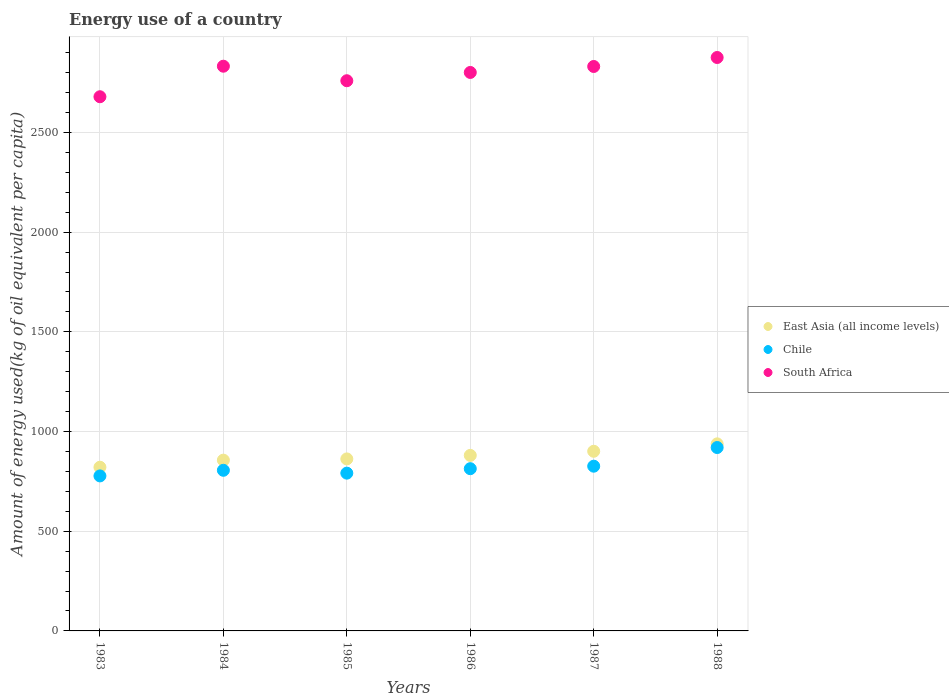What is the amount of energy used in in Chile in 1988?
Give a very brief answer. 919.89. Across all years, what is the maximum amount of energy used in in Chile?
Your answer should be compact. 919.89. Across all years, what is the minimum amount of energy used in in Chile?
Provide a succinct answer. 777.5. What is the total amount of energy used in in East Asia (all income levels) in the graph?
Make the answer very short. 5260.38. What is the difference between the amount of energy used in in South Africa in 1985 and that in 1986?
Ensure brevity in your answer.  -41.53. What is the difference between the amount of energy used in in East Asia (all income levels) in 1983 and the amount of energy used in in Chile in 1986?
Give a very brief answer. 7.35. What is the average amount of energy used in in East Asia (all income levels) per year?
Keep it short and to the point. 876.73. In the year 1984, what is the difference between the amount of energy used in in South Africa and amount of energy used in in Chile?
Your answer should be very brief. 2026.84. In how many years, is the amount of energy used in in South Africa greater than 200 kg?
Make the answer very short. 6. What is the ratio of the amount of energy used in in East Asia (all income levels) in 1985 to that in 1986?
Your response must be concise. 0.98. What is the difference between the highest and the second highest amount of energy used in in Chile?
Make the answer very short. 93.63. What is the difference between the highest and the lowest amount of energy used in in South Africa?
Your answer should be compact. 196.85. Is the amount of energy used in in Chile strictly greater than the amount of energy used in in East Asia (all income levels) over the years?
Your answer should be very brief. No. How many dotlines are there?
Offer a very short reply. 3. What is the difference between two consecutive major ticks on the Y-axis?
Keep it short and to the point. 500. Where does the legend appear in the graph?
Provide a succinct answer. Center right. How are the legend labels stacked?
Offer a terse response. Vertical. What is the title of the graph?
Provide a succinct answer. Energy use of a country. Does "New Zealand" appear as one of the legend labels in the graph?
Offer a very short reply. No. What is the label or title of the Y-axis?
Your answer should be compact. Amount of energy used(kg of oil equivalent per capita). What is the Amount of energy used(kg of oil equivalent per capita) in East Asia (all income levels) in 1983?
Provide a succinct answer. 821.1. What is the Amount of energy used(kg of oil equivalent per capita) in Chile in 1983?
Your answer should be compact. 777.5. What is the Amount of energy used(kg of oil equivalent per capita) in South Africa in 1983?
Make the answer very short. 2679.38. What is the Amount of energy used(kg of oil equivalent per capita) in East Asia (all income levels) in 1984?
Offer a terse response. 856.58. What is the Amount of energy used(kg of oil equivalent per capita) in Chile in 1984?
Provide a short and direct response. 805.69. What is the Amount of energy used(kg of oil equivalent per capita) of South Africa in 1984?
Your response must be concise. 2832.52. What is the Amount of energy used(kg of oil equivalent per capita) in East Asia (all income levels) in 1985?
Make the answer very short. 862.8. What is the Amount of energy used(kg of oil equivalent per capita) in Chile in 1985?
Offer a very short reply. 791.4. What is the Amount of energy used(kg of oil equivalent per capita) of South Africa in 1985?
Your answer should be compact. 2759.69. What is the Amount of energy used(kg of oil equivalent per capita) in East Asia (all income levels) in 1986?
Provide a short and direct response. 880.44. What is the Amount of energy used(kg of oil equivalent per capita) in Chile in 1986?
Your answer should be compact. 813.75. What is the Amount of energy used(kg of oil equivalent per capita) of South Africa in 1986?
Your answer should be compact. 2801.22. What is the Amount of energy used(kg of oil equivalent per capita) in East Asia (all income levels) in 1987?
Your response must be concise. 901.11. What is the Amount of energy used(kg of oil equivalent per capita) of Chile in 1987?
Provide a succinct answer. 826.26. What is the Amount of energy used(kg of oil equivalent per capita) of South Africa in 1987?
Your response must be concise. 2831.15. What is the Amount of energy used(kg of oil equivalent per capita) in East Asia (all income levels) in 1988?
Offer a very short reply. 938.34. What is the Amount of energy used(kg of oil equivalent per capita) of Chile in 1988?
Your answer should be compact. 919.89. What is the Amount of energy used(kg of oil equivalent per capita) in South Africa in 1988?
Provide a short and direct response. 2876.23. Across all years, what is the maximum Amount of energy used(kg of oil equivalent per capita) of East Asia (all income levels)?
Provide a succinct answer. 938.34. Across all years, what is the maximum Amount of energy used(kg of oil equivalent per capita) of Chile?
Your response must be concise. 919.89. Across all years, what is the maximum Amount of energy used(kg of oil equivalent per capita) of South Africa?
Provide a short and direct response. 2876.23. Across all years, what is the minimum Amount of energy used(kg of oil equivalent per capita) of East Asia (all income levels)?
Ensure brevity in your answer.  821.1. Across all years, what is the minimum Amount of energy used(kg of oil equivalent per capita) in Chile?
Give a very brief answer. 777.5. Across all years, what is the minimum Amount of energy used(kg of oil equivalent per capita) in South Africa?
Your response must be concise. 2679.38. What is the total Amount of energy used(kg of oil equivalent per capita) in East Asia (all income levels) in the graph?
Provide a succinct answer. 5260.38. What is the total Amount of energy used(kg of oil equivalent per capita) in Chile in the graph?
Ensure brevity in your answer.  4934.48. What is the total Amount of energy used(kg of oil equivalent per capita) in South Africa in the graph?
Your response must be concise. 1.68e+04. What is the difference between the Amount of energy used(kg of oil equivalent per capita) of East Asia (all income levels) in 1983 and that in 1984?
Offer a very short reply. -35.48. What is the difference between the Amount of energy used(kg of oil equivalent per capita) in Chile in 1983 and that in 1984?
Provide a short and direct response. -28.19. What is the difference between the Amount of energy used(kg of oil equivalent per capita) in South Africa in 1983 and that in 1984?
Provide a short and direct response. -153.14. What is the difference between the Amount of energy used(kg of oil equivalent per capita) of East Asia (all income levels) in 1983 and that in 1985?
Ensure brevity in your answer.  -41.69. What is the difference between the Amount of energy used(kg of oil equivalent per capita) of Chile in 1983 and that in 1985?
Ensure brevity in your answer.  -13.9. What is the difference between the Amount of energy used(kg of oil equivalent per capita) in South Africa in 1983 and that in 1985?
Offer a terse response. -80.31. What is the difference between the Amount of energy used(kg of oil equivalent per capita) in East Asia (all income levels) in 1983 and that in 1986?
Provide a short and direct response. -59.34. What is the difference between the Amount of energy used(kg of oil equivalent per capita) of Chile in 1983 and that in 1986?
Make the answer very short. -36.26. What is the difference between the Amount of energy used(kg of oil equivalent per capita) of South Africa in 1983 and that in 1986?
Provide a short and direct response. -121.84. What is the difference between the Amount of energy used(kg of oil equivalent per capita) of East Asia (all income levels) in 1983 and that in 1987?
Provide a short and direct response. -80. What is the difference between the Amount of energy used(kg of oil equivalent per capita) of Chile in 1983 and that in 1987?
Ensure brevity in your answer.  -48.77. What is the difference between the Amount of energy used(kg of oil equivalent per capita) in South Africa in 1983 and that in 1987?
Offer a very short reply. -151.77. What is the difference between the Amount of energy used(kg of oil equivalent per capita) in East Asia (all income levels) in 1983 and that in 1988?
Provide a succinct answer. -117.24. What is the difference between the Amount of energy used(kg of oil equivalent per capita) of Chile in 1983 and that in 1988?
Make the answer very short. -142.4. What is the difference between the Amount of energy used(kg of oil equivalent per capita) in South Africa in 1983 and that in 1988?
Your answer should be very brief. -196.85. What is the difference between the Amount of energy used(kg of oil equivalent per capita) of East Asia (all income levels) in 1984 and that in 1985?
Your answer should be very brief. -6.21. What is the difference between the Amount of energy used(kg of oil equivalent per capita) in Chile in 1984 and that in 1985?
Ensure brevity in your answer.  14.29. What is the difference between the Amount of energy used(kg of oil equivalent per capita) in South Africa in 1984 and that in 1985?
Your answer should be compact. 72.83. What is the difference between the Amount of energy used(kg of oil equivalent per capita) of East Asia (all income levels) in 1984 and that in 1986?
Your answer should be compact. -23.86. What is the difference between the Amount of energy used(kg of oil equivalent per capita) of Chile in 1984 and that in 1986?
Your answer should be compact. -8.07. What is the difference between the Amount of energy used(kg of oil equivalent per capita) of South Africa in 1984 and that in 1986?
Keep it short and to the point. 31.3. What is the difference between the Amount of energy used(kg of oil equivalent per capita) of East Asia (all income levels) in 1984 and that in 1987?
Make the answer very short. -44.53. What is the difference between the Amount of energy used(kg of oil equivalent per capita) in Chile in 1984 and that in 1987?
Offer a terse response. -20.57. What is the difference between the Amount of energy used(kg of oil equivalent per capita) of South Africa in 1984 and that in 1987?
Offer a terse response. 1.38. What is the difference between the Amount of energy used(kg of oil equivalent per capita) of East Asia (all income levels) in 1984 and that in 1988?
Offer a very short reply. -81.76. What is the difference between the Amount of energy used(kg of oil equivalent per capita) of Chile in 1984 and that in 1988?
Your answer should be very brief. -114.2. What is the difference between the Amount of energy used(kg of oil equivalent per capita) of South Africa in 1984 and that in 1988?
Offer a very short reply. -43.71. What is the difference between the Amount of energy used(kg of oil equivalent per capita) of East Asia (all income levels) in 1985 and that in 1986?
Provide a short and direct response. -17.65. What is the difference between the Amount of energy used(kg of oil equivalent per capita) of Chile in 1985 and that in 1986?
Your response must be concise. -22.36. What is the difference between the Amount of energy used(kg of oil equivalent per capita) in South Africa in 1985 and that in 1986?
Give a very brief answer. -41.53. What is the difference between the Amount of energy used(kg of oil equivalent per capita) of East Asia (all income levels) in 1985 and that in 1987?
Offer a terse response. -38.31. What is the difference between the Amount of energy used(kg of oil equivalent per capita) in Chile in 1985 and that in 1987?
Offer a very short reply. -34.87. What is the difference between the Amount of energy used(kg of oil equivalent per capita) of South Africa in 1985 and that in 1987?
Your response must be concise. -71.46. What is the difference between the Amount of energy used(kg of oil equivalent per capita) of East Asia (all income levels) in 1985 and that in 1988?
Provide a short and direct response. -75.55. What is the difference between the Amount of energy used(kg of oil equivalent per capita) in Chile in 1985 and that in 1988?
Give a very brief answer. -128.49. What is the difference between the Amount of energy used(kg of oil equivalent per capita) of South Africa in 1985 and that in 1988?
Your answer should be compact. -116.54. What is the difference between the Amount of energy used(kg of oil equivalent per capita) in East Asia (all income levels) in 1986 and that in 1987?
Offer a very short reply. -20.67. What is the difference between the Amount of energy used(kg of oil equivalent per capita) of Chile in 1986 and that in 1987?
Give a very brief answer. -12.51. What is the difference between the Amount of energy used(kg of oil equivalent per capita) in South Africa in 1986 and that in 1987?
Keep it short and to the point. -29.93. What is the difference between the Amount of energy used(kg of oil equivalent per capita) in East Asia (all income levels) in 1986 and that in 1988?
Your answer should be very brief. -57.9. What is the difference between the Amount of energy used(kg of oil equivalent per capita) of Chile in 1986 and that in 1988?
Your response must be concise. -106.14. What is the difference between the Amount of energy used(kg of oil equivalent per capita) in South Africa in 1986 and that in 1988?
Keep it short and to the point. -75.01. What is the difference between the Amount of energy used(kg of oil equivalent per capita) in East Asia (all income levels) in 1987 and that in 1988?
Your answer should be very brief. -37.23. What is the difference between the Amount of energy used(kg of oil equivalent per capita) of Chile in 1987 and that in 1988?
Offer a terse response. -93.63. What is the difference between the Amount of energy used(kg of oil equivalent per capita) in South Africa in 1987 and that in 1988?
Offer a very short reply. -45.08. What is the difference between the Amount of energy used(kg of oil equivalent per capita) in East Asia (all income levels) in 1983 and the Amount of energy used(kg of oil equivalent per capita) in Chile in 1984?
Offer a very short reply. 15.42. What is the difference between the Amount of energy used(kg of oil equivalent per capita) in East Asia (all income levels) in 1983 and the Amount of energy used(kg of oil equivalent per capita) in South Africa in 1984?
Give a very brief answer. -2011.42. What is the difference between the Amount of energy used(kg of oil equivalent per capita) of Chile in 1983 and the Amount of energy used(kg of oil equivalent per capita) of South Africa in 1984?
Make the answer very short. -2055.03. What is the difference between the Amount of energy used(kg of oil equivalent per capita) of East Asia (all income levels) in 1983 and the Amount of energy used(kg of oil equivalent per capita) of Chile in 1985?
Provide a succinct answer. 29.71. What is the difference between the Amount of energy used(kg of oil equivalent per capita) in East Asia (all income levels) in 1983 and the Amount of energy used(kg of oil equivalent per capita) in South Africa in 1985?
Ensure brevity in your answer.  -1938.59. What is the difference between the Amount of energy used(kg of oil equivalent per capita) in Chile in 1983 and the Amount of energy used(kg of oil equivalent per capita) in South Africa in 1985?
Your answer should be very brief. -1982.2. What is the difference between the Amount of energy used(kg of oil equivalent per capita) of East Asia (all income levels) in 1983 and the Amount of energy used(kg of oil equivalent per capita) of Chile in 1986?
Your answer should be compact. 7.35. What is the difference between the Amount of energy used(kg of oil equivalent per capita) in East Asia (all income levels) in 1983 and the Amount of energy used(kg of oil equivalent per capita) in South Africa in 1986?
Give a very brief answer. -1980.12. What is the difference between the Amount of energy used(kg of oil equivalent per capita) in Chile in 1983 and the Amount of energy used(kg of oil equivalent per capita) in South Africa in 1986?
Your answer should be very brief. -2023.72. What is the difference between the Amount of energy used(kg of oil equivalent per capita) of East Asia (all income levels) in 1983 and the Amount of energy used(kg of oil equivalent per capita) of Chile in 1987?
Provide a short and direct response. -5.16. What is the difference between the Amount of energy used(kg of oil equivalent per capita) of East Asia (all income levels) in 1983 and the Amount of energy used(kg of oil equivalent per capita) of South Africa in 1987?
Provide a short and direct response. -2010.04. What is the difference between the Amount of energy used(kg of oil equivalent per capita) in Chile in 1983 and the Amount of energy used(kg of oil equivalent per capita) in South Africa in 1987?
Offer a terse response. -2053.65. What is the difference between the Amount of energy used(kg of oil equivalent per capita) in East Asia (all income levels) in 1983 and the Amount of energy used(kg of oil equivalent per capita) in Chile in 1988?
Provide a succinct answer. -98.79. What is the difference between the Amount of energy used(kg of oil equivalent per capita) in East Asia (all income levels) in 1983 and the Amount of energy used(kg of oil equivalent per capita) in South Africa in 1988?
Your response must be concise. -2055.13. What is the difference between the Amount of energy used(kg of oil equivalent per capita) in Chile in 1983 and the Amount of energy used(kg of oil equivalent per capita) in South Africa in 1988?
Ensure brevity in your answer.  -2098.74. What is the difference between the Amount of energy used(kg of oil equivalent per capita) of East Asia (all income levels) in 1984 and the Amount of energy used(kg of oil equivalent per capita) of Chile in 1985?
Give a very brief answer. 65.19. What is the difference between the Amount of energy used(kg of oil equivalent per capita) of East Asia (all income levels) in 1984 and the Amount of energy used(kg of oil equivalent per capita) of South Africa in 1985?
Give a very brief answer. -1903.11. What is the difference between the Amount of energy used(kg of oil equivalent per capita) of Chile in 1984 and the Amount of energy used(kg of oil equivalent per capita) of South Africa in 1985?
Ensure brevity in your answer.  -1954. What is the difference between the Amount of energy used(kg of oil equivalent per capita) in East Asia (all income levels) in 1984 and the Amount of energy used(kg of oil equivalent per capita) in Chile in 1986?
Your answer should be compact. 42.83. What is the difference between the Amount of energy used(kg of oil equivalent per capita) in East Asia (all income levels) in 1984 and the Amount of energy used(kg of oil equivalent per capita) in South Africa in 1986?
Make the answer very short. -1944.64. What is the difference between the Amount of energy used(kg of oil equivalent per capita) in Chile in 1984 and the Amount of energy used(kg of oil equivalent per capita) in South Africa in 1986?
Give a very brief answer. -1995.53. What is the difference between the Amount of energy used(kg of oil equivalent per capita) of East Asia (all income levels) in 1984 and the Amount of energy used(kg of oil equivalent per capita) of Chile in 1987?
Offer a terse response. 30.32. What is the difference between the Amount of energy used(kg of oil equivalent per capita) in East Asia (all income levels) in 1984 and the Amount of energy used(kg of oil equivalent per capita) in South Africa in 1987?
Provide a short and direct response. -1974.57. What is the difference between the Amount of energy used(kg of oil equivalent per capita) in Chile in 1984 and the Amount of energy used(kg of oil equivalent per capita) in South Africa in 1987?
Keep it short and to the point. -2025.46. What is the difference between the Amount of energy used(kg of oil equivalent per capita) in East Asia (all income levels) in 1984 and the Amount of energy used(kg of oil equivalent per capita) in Chile in 1988?
Offer a very short reply. -63.31. What is the difference between the Amount of energy used(kg of oil equivalent per capita) in East Asia (all income levels) in 1984 and the Amount of energy used(kg of oil equivalent per capita) in South Africa in 1988?
Give a very brief answer. -2019.65. What is the difference between the Amount of energy used(kg of oil equivalent per capita) of Chile in 1984 and the Amount of energy used(kg of oil equivalent per capita) of South Africa in 1988?
Your answer should be compact. -2070.54. What is the difference between the Amount of energy used(kg of oil equivalent per capita) in East Asia (all income levels) in 1985 and the Amount of energy used(kg of oil equivalent per capita) in Chile in 1986?
Provide a short and direct response. 49.04. What is the difference between the Amount of energy used(kg of oil equivalent per capita) of East Asia (all income levels) in 1985 and the Amount of energy used(kg of oil equivalent per capita) of South Africa in 1986?
Ensure brevity in your answer.  -1938.42. What is the difference between the Amount of energy used(kg of oil equivalent per capita) of Chile in 1985 and the Amount of energy used(kg of oil equivalent per capita) of South Africa in 1986?
Your answer should be very brief. -2009.82. What is the difference between the Amount of energy used(kg of oil equivalent per capita) in East Asia (all income levels) in 1985 and the Amount of energy used(kg of oil equivalent per capita) in Chile in 1987?
Make the answer very short. 36.53. What is the difference between the Amount of energy used(kg of oil equivalent per capita) of East Asia (all income levels) in 1985 and the Amount of energy used(kg of oil equivalent per capita) of South Africa in 1987?
Ensure brevity in your answer.  -1968.35. What is the difference between the Amount of energy used(kg of oil equivalent per capita) of Chile in 1985 and the Amount of energy used(kg of oil equivalent per capita) of South Africa in 1987?
Offer a terse response. -2039.75. What is the difference between the Amount of energy used(kg of oil equivalent per capita) of East Asia (all income levels) in 1985 and the Amount of energy used(kg of oil equivalent per capita) of Chile in 1988?
Your response must be concise. -57.09. What is the difference between the Amount of energy used(kg of oil equivalent per capita) of East Asia (all income levels) in 1985 and the Amount of energy used(kg of oil equivalent per capita) of South Africa in 1988?
Keep it short and to the point. -2013.44. What is the difference between the Amount of energy used(kg of oil equivalent per capita) of Chile in 1985 and the Amount of energy used(kg of oil equivalent per capita) of South Africa in 1988?
Keep it short and to the point. -2084.84. What is the difference between the Amount of energy used(kg of oil equivalent per capita) in East Asia (all income levels) in 1986 and the Amount of energy used(kg of oil equivalent per capita) in Chile in 1987?
Offer a very short reply. 54.18. What is the difference between the Amount of energy used(kg of oil equivalent per capita) in East Asia (all income levels) in 1986 and the Amount of energy used(kg of oil equivalent per capita) in South Africa in 1987?
Ensure brevity in your answer.  -1950.7. What is the difference between the Amount of energy used(kg of oil equivalent per capita) in Chile in 1986 and the Amount of energy used(kg of oil equivalent per capita) in South Africa in 1987?
Your answer should be compact. -2017.4. What is the difference between the Amount of energy used(kg of oil equivalent per capita) in East Asia (all income levels) in 1986 and the Amount of energy used(kg of oil equivalent per capita) in Chile in 1988?
Offer a very short reply. -39.45. What is the difference between the Amount of energy used(kg of oil equivalent per capita) in East Asia (all income levels) in 1986 and the Amount of energy used(kg of oil equivalent per capita) in South Africa in 1988?
Your answer should be very brief. -1995.79. What is the difference between the Amount of energy used(kg of oil equivalent per capita) of Chile in 1986 and the Amount of energy used(kg of oil equivalent per capita) of South Africa in 1988?
Provide a succinct answer. -2062.48. What is the difference between the Amount of energy used(kg of oil equivalent per capita) of East Asia (all income levels) in 1987 and the Amount of energy used(kg of oil equivalent per capita) of Chile in 1988?
Ensure brevity in your answer.  -18.78. What is the difference between the Amount of energy used(kg of oil equivalent per capita) in East Asia (all income levels) in 1987 and the Amount of energy used(kg of oil equivalent per capita) in South Africa in 1988?
Offer a terse response. -1975.12. What is the difference between the Amount of energy used(kg of oil equivalent per capita) of Chile in 1987 and the Amount of energy used(kg of oil equivalent per capita) of South Africa in 1988?
Keep it short and to the point. -2049.97. What is the average Amount of energy used(kg of oil equivalent per capita) in East Asia (all income levels) per year?
Make the answer very short. 876.73. What is the average Amount of energy used(kg of oil equivalent per capita) of Chile per year?
Your answer should be very brief. 822.41. What is the average Amount of energy used(kg of oil equivalent per capita) of South Africa per year?
Provide a succinct answer. 2796.7. In the year 1983, what is the difference between the Amount of energy used(kg of oil equivalent per capita) in East Asia (all income levels) and Amount of energy used(kg of oil equivalent per capita) in Chile?
Provide a succinct answer. 43.61. In the year 1983, what is the difference between the Amount of energy used(kg of oil equivalent per capita) of East Asia (all income levels) and Amount of energy used(kg of oil equivalent per capita) of South Africa?
Make the answer very short. -1858.27. In the year 1983, what is the difference between the Amount of energy used(kg of oil equivalent per capita) of Chile and Amount of energy used(kg of oil equivalent per capita) of South Africa?
Your answer should be very brief. -1901.88. In the year 1984, what is the difference between the Amount of energy used(kg of oil equivalent per capita) in East Asia (all income levels) and Amount of energy used(kg of oil equivalent per capita) in Chile?
Keep it short and to the point. 50.9. In the year 1984, what is the difference between the Amount of energy used(kg of oil equivalent per capita) of East Asia (all income levels) and Amount of energy used(kg of oil equivalent per capita) of South Africa?
Your answer should be very brief. -1975.94. In the year 1984, what is the difference between the Amount of energy used(kg of oil equivalent per capita) of Chile and Amount of energy used(kg of oil equivalent per capita) of South Africa?
Give a very brief answer. -2026.84. In the year 1985, what is the difference between the Amount of energy used(kg of oil equivalent per capita) of East Asia (all income levels) and Amount of energy used(kg of oil equivalent per capita) of Chile?
Provide a short and direct response. 71.4. In the year 1985, what is the difference between the Amount of energy used(kg of oil equivalent per capita) in East Asia (all income levels) and Amount of energy used(kg of oil equivalent per capita) in South Africa?
Offer a terse response. -1896.9. In the year 1985, what is the difference between the Amount of energy used(kg of oil equivalent per capita) of Chile and Amount of energy used(kg of oil equivalent per capita) of South Africa?
Give a very brief answer. -1968.3. In the year 1986, what is the difference between the Amount of energy used(kg of oil equivalent per capita) in East Asia (all income levels) and Amount of energy used(kg of oil equivalent per capita) in Chile?
Make the answer very short. 66.69. In the year 1986, what is the difference between the Amount of energy used(kg of oil equivalent per capita) of East Asia (all income levels) and Amount of energy used(kg of oil equivalent per capita) of South Africa?
Provide a short and direct response. -1920.78. In the year 1986, what is the difference between the Amount of energy used(kg of oil equivalent per capita) in Chile and Amount of energy used(kg of oil equivalent per capita) in South Africa?
Offer a terse response. -1987.47. In the year 1987, what is the difference between the Amount of energy used(kg of oil equivalent per capita) in East Asia (all income levels) and Amount of energy used(kg of oil equivalent per capita) in Chile?
Offer a terse response. 74.85. In the year 1987, what is the difference between the Amount of energy used(kg of oil equivalent per capita) of East Asia (all income levels) and Amount of energy used(kg of oil equivalent per capita) of South Africa?
Your answer should be compact. -1930.04. In the year 1987, what is the difference between the Amount of energy used(kg of oil equivalent per capita) of Chile and Amount of energy used(kg of oil equivalent per capita) of South Africa?
Offer a very short reply. -2004.89. In the year 1988, what is the difference between the Amount of energy used(kg of oil equivalent per capita) of East Asia (all income levels) and Amount of energy used(kg of oil equivalent per capita) of Chile?
Ensure brevity in your answer.  18.45. In the year 1988, what is the difference between the Amount of energy used(kg of oil equivalent per capita) in East Asia (all income levels) and Amount of energy used(kg of oil equivalent per capita) in South Africa?
Provide a short and direct response. -1937.89. In the year 1988, what is the difference between the Amount of energy used(kg of oil equivalent per capita) in Chile and Amount of energy used(kg of oil equivalent per capita) in South Africa?
Give a very brief answer. -1956.34. What is the ratio of the Amount of energy used(kg of oil equivalent per capita) in East Asia (all income levels) in 1983 to that in 1984?
Make the answer very short. 0.96. What is the ratio of the Amount of energy used(kg of oil equivalent per capita) of Chile in 1983 to that in 1984?
Your answer should be very brief. 0.96. What is the ratio of the Amount of energy used(kg of oil equivalent per capita) in South Africa in 1983 to that in 1984?
Keep it short and to the point. 0.95. What is the ratio of the Amount of energy used(kg of oil equivalent per capita) in East Asia (all income levels) in 1983 to that in 1985?
Your response must be concise. 0.95. What is the ratio of the Amount of energy used(kg of oil equivalent per capita) in Chile in 1983 to that in 1985?
Give a very brief answer. 0.98. What is the ratio of the Amount of energy used(kg of oil equivalent per capita) of South Africa in 1983 to that in 1985?
Give a very brief answer. 0.97. What is the ratio of the Amount of energy used(kg of oil equivalent per capita) of East Asia (all income levels) in 1983 to that in 1986?
Offer a terse response. 0.93. What is the ratio of the Amount of energy used(kg of oil equivalent per capita) of Chile in 1983 to that in 1986?
Provide a succinct answer. 0.96. What is the ratio of the Amount of energy used(kg of oil equivalent per capita) in South Africa in 1983 to that in 1986?
Make the answer very short. 0.96. What is the ratio of the Amount of energy used(kg of oil equivalent per capita) of East Asia (all income levels) in 1983 to that in 1987?
Offer a terse response. 0.91. What is the ratio of the Amount of energy used(kg of oil equivalent per capita) in Chile in 1983 to that in 1987?
Your answer should be very brief. 0.94. What is the ratio of the Amount of energy used(kg of oil equivalent per capita) of South Africa in 1983 to that in 1987?
Offer a terse response. 0.95. What is the ratio of the Amount of energy used(kg of oil equivalent per capita) of East Asia (all income levels) in 1983 to that in 1988?
Offer a terse response. 0.88. What is the ratio of the Amount of energy used(kg of oil equivalent per capita) of Chile in 1983 to that in 1988?
Make the answer very short. 0.85. What is the ratio of the Amount of energy used(kg of oil equivalent per capita) of South Africa in 1983 to that in 1988?
Provide a succinct answer. 0.93. What is the ratio of the Amount of energy used(kg of oil equivalent per capita) of East Asia (all income levels) in 1984 to that in 1985?
Ensure brevity in your answer.  0.99. What is the ratio of the Amount of energy used(kg of oil equivalent per capita) of Chile in 1984 to that in 1985?
Make the answer very short. 1.02. What is the ratio of the Amount of energy used(kg of oil equivalent per capita) of South Africa in 1984 to that in 1985?
Your answer should be compact. 1.03. What is the ratio of the Amount of energy used(kg of oil equivalent per capita) in East Asia (all income levels) in 1984 to that in 1986?
Make the answer very short. 0.97. What is the ratio of the Amount of energy used(kg of oil equivalent per capita) in South Africa in 1984 to that in 1986?
Your response must be concise. 1.01. What is the ratio of the Amount of energy used(kg of oil equivalent per capita) of East Asia (all income levels) in 1984 to that in 1987?
Offer a terse response. 0.95. What is the ratio of the Amount of energy used(kg of oil equivalent per capita) of Chile in 1984 to that in 1987?
Your answer should be very brief. 0.98. What is the ratio of the Amount of energy used(kg of oil equivalent per capita) in East Asia (all income levels) in 1984 to that in 1988?
Offer a very short reply. 0.91. What is the ratio of the Amount of energy used(kg of oil equivalent per capita) of Chile in 1984 to that in 1988?
Your response must be concise. 0.88. What is the ratio of the Amount of energy used(kg of oil equivalent per capita) of Chile in 1985 to that in 1986?
Provide a succinct answer. 0.97. What is the ratio of the Amount of energy used(kg of oil equivalent per capita) of South Africa in 1985 to that in 1986?
Ensure brevity in your answer.  0.99. What is the ratio of the Amount of energy used(kg of oil equivalent per capita) in East Asia (all income levels) in 1985 to that in 1987?
Your answer should be very brief. 0.96. What is the ratio of the Amount of energy used(kg of oil equivalent per capita) of Chile in 1985 to that in 1987?
Offer a terse response. 0.96. What is the ratio of the Amount of energy used(kg of oil equivalent per capita) of South Africa in 1985 to that in 1987?
Give a very brief answer. 0.97. What is the ratio of the Amount of energy used(kg of oil equivalent per capita) in East Asia (all income levels) in 1985 to that in 1988?
Your answer should be very brief. 0.92. What is the ratio of the Amount of energy used(kg of oil equivalent per capita) of Chile in 1985 to that in 1988?
Give a very brief answer. 0.86. What is the ratio of the Amount of energy used(kg of oil equivalent per capita) in South Africa in 1985 to that in 1988?
Offer a very short reply. 0.96. What is the ratio of the Amount of energy used(kg of oil equivalent per capita) of East Asia (all income levels) in 1986 to that in 1987?
Make the answer very short. 0.98. What is the ratio of the Amount of energy used(kg of oil equivalent per capita) of Chile in 1986 to that in 1987?
Provide a short and direct response. 0.98. What is the ratio of the Amount of energy used(kg of oil equivalent per capita) of East Asia (all income levels) in 1986 to that in 1988?
Offer a terse response. 0.94. What is the ratio of the Amount of energy used(kg of oil equivalent per capita) in Chile in 1986 to that in 1988?
Offer a very short reply. 0.88. What is the ratio of the Amount of energy used(kg of oil equivalent per capita) in South Africa in 1986 to that in 1988?
Keep it short and to the point. 0.97. What is the ratio of the Amount of energy used(kg of oil equivalent per capita) of East Asia (all income levels) in 1987 to that in 1988?
Give a very brief answer. 0.96. What is the ratio of the Amount of energy used(kg of oil equivalent per capita) of Chile in 1987 to that in 1988?
Your answer should be compact. 0.9. What is the ratio of the Amount of energy used(kg of oil equivalent per capita) of South Africa in 1987 to that in 1988?
Ensure brevity in your answer.  0.98. What is the difference between the highest and the second highest Amount of energy used(kg of oil equivalent per capita) in East Asia (all income levels)?
Keep it short and to the point. 37.23. What is the difference between the highest and the second highest Amount of energy used(kg of oil equivalent per capita) in Chile?
Make the answer very short. 93.63. What is the difference between the highest and the second highest Amount of energy used(kg of oil equivalent per capita) in South Africa?
Make the answer very short. 43.71. What is the difference between the highest and the lowest Amount of energy used(kg of oil equivalent per capita) in East Asia (all income levels)?
Keep it short and to the point. 117.24. What is the difference between the highest and the lowest Amount of energy used(kg of oil equivalent per capita) of Chile?
Provide a succinct answer. 142.4. What is the difference between the highest and the lowest Amount of energy used(kg of oil equivalent per capita) in South Africa?
Provide a short and direct response. 196.85. 